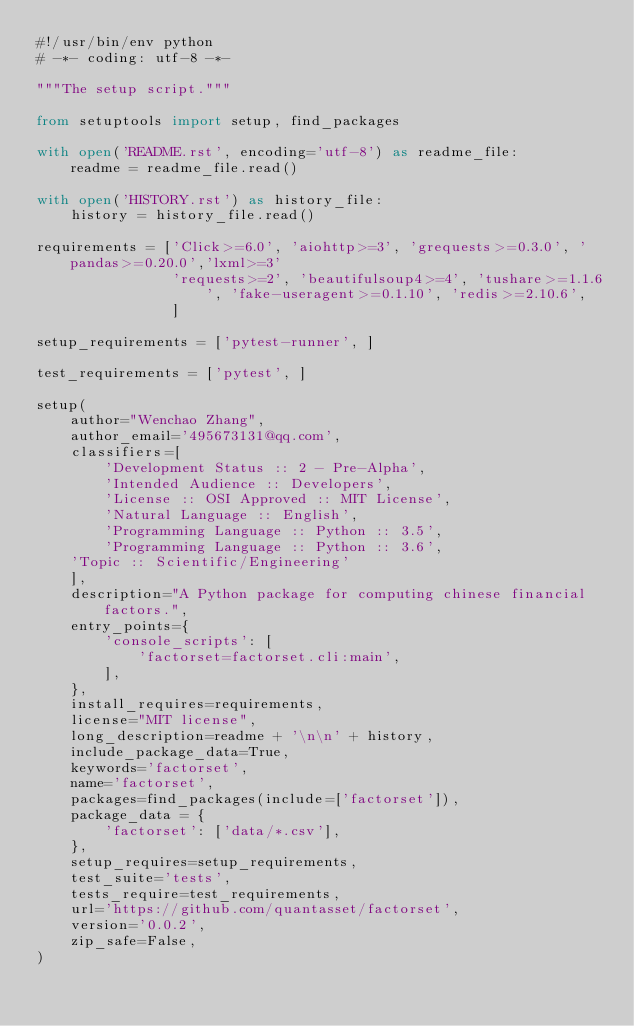Convert code to text. <code><loc_0><loc_0><loc_500><loc_500><_Python_>#!/usr/bin/env python
# -*- coding: utf-8 -*-

"""The setup script."""

from setuptools import setup, find_packages

with open('README.rst', encoding='utf-8') as readme_file:
    readme = readme_file.read()

with open('HISTORY.rst') as history_file:
    history = history_file.read()

requirements = ['Click>=6.0', 'aiohttp>=3', 'grequests>=0.3.0', 'pandas>=0.20.0','lxml>=3'
                'requests>=2', 'beautifulsoup4>=4', 'tushare>=1.1.6', 'fake-useragent>=0.1.10', 'redis>=2.10.6',
                ]

setup_requirements = ['pytest-runner', ]

test_requirements = ['pytest', ]

setup(
    author="Wenchao Zhang",
    author_email='495673131@qq.com',
    classifiers=[
        'Development Status :: 2 - Pre-Alpha',
        'Intended Audience :: Developers',
        'License :: OSI Approved :: MIT License',
        'Natural Language :: English',
        'Programming Language :: Python :: 3.5',
        'Programming Language :: Python :: 3.6',
		'Topic :: Scientific/Engineering'
    ],
    description="A Python package for computing chinese financial factors.",
    entry_points={
        'console_scripts': [
            'factorset=factorset.cli:main',
        ],
    },
    install_requires=requirements,
    license="MIT license",
    long_description=readme + '\n\n' + history,
    include_package_data=True,
    keywords='factorset',
    name='factorset',
    packages=find_packages(include=['factorset']),
    package_data = {
        'factorset': ['data/*.csv'],
    },
    setup_requires=setup_requirements,
    test_suite='tests',
    tests_require=test_requirements,
    url='https://github.com/quantasset/factorset',
    version='0.0.2',
    zip_safe=False,
)
</code> 